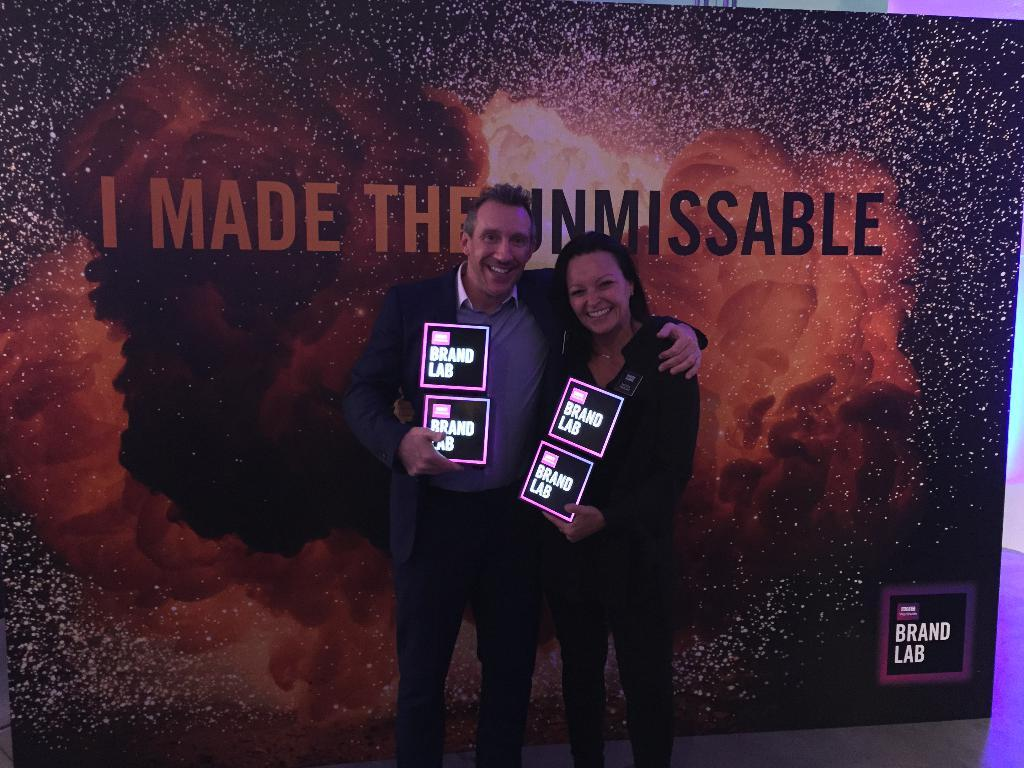How many people are in the image? There are two people in the image. What are the people doing in the image? The people are standing and holding boards in their hands. What can be seen in the background of the image? There is a banner with text in the background of the image. What type of spark can be seen coming from the boards in the image? There is no spark visible in the image; the people are simply holding boards in their hands. 